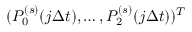Convert formula to latex. <formula><loc_0><loc_0><loc_500><loc_500>( P _ { 0 } ^ { ( s ) } ( j \Delta t ) , \dots , P _ { 2 } ^ { ( s ) } ( j \Delta t ) ) ^ { T }</formula> 